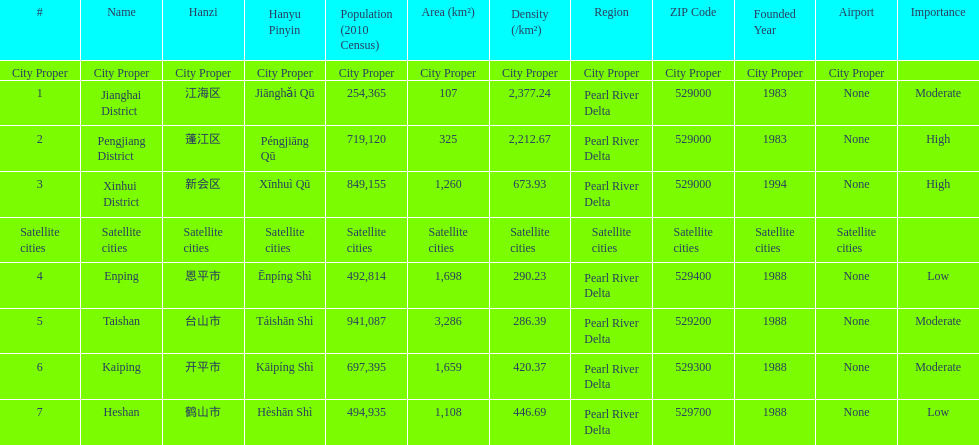Is enping more/less dense than kaiping? Less. Can you parse all the data within this table? {'header': ['#', 'Name', 'Hanzi', 'Hanyu Pinyin', 'Population (2010 Census)', 'Area (km²)', 'Density (/km²)', 'Region', 'ZIP Code', 'Founded Year', 'Airport', 'Importance'], 'rows': [['City Proper', 'City Proper', 'City Proper', 'City Proper', 'City Proper', 'City Proper', 'City Proper', 'City Proper', 'City Proper', 'City Proper', 'City Proper', ''], ['1', 'Jianghai District', '江海区', 'Jiānghǎi Qū', '254,365', '107', '2,377.24', 'Pearl River Delta', '529000', '1983', 'None', 'Moderate'], ['2', 'Pengjiang District', '蓬江区', 'Péngjiāng Qū', '719,120', '325', '2,212.67', 'Pearl River Delta', '529000', '1983', 'None', 'High'], ['3', 'Xinhui District', '新会区', 'Xīnhuì Qū', '849,155', '1,260', '673.93', 'Pearl River Delta', '529000', '1994', 'None', 'High'], ['Satellite cities', 'Satellite cities', 'Satellite cities', 'Satellite cities', 'Satellite cities', 'Satellite cities', 'Satellite cities', 'Satellite cities', 'Satellite cities', 'Satellite cities', 'Satellite cities', ''], ['4', 'Enping', '恩平市', 'Ēnpíng Shì', '492,814', '1,698', '290.23', 'Pearl River Delta', '529400', '1988', 'None', 'Low'], ['5', 'Taishan', '台山市', 'Táishān Shì', '941,087', '3,286', '286.39', 'Pearl River Delta', '529200', '1988', 'None', 'Moderate'], ['6', 'Kaiping', '开平市', 'Kāipíng Shì', '697,395', '1,659', '420.37', 'Pearl River Delta', '529300', '1988', 'None', 'Moderate'], ['7', 'Heshan', '鹤山市', 'Hèshān Shì', '494,935', '1,108', '446.69', 'Pearl River Delta', '529700', '1988', 'None', 'Low']]} 